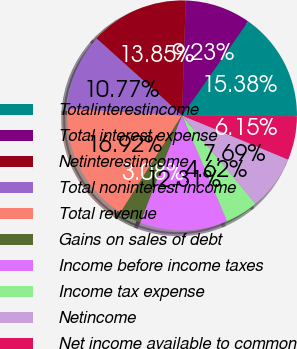<chart> <loc_0><loc_0><loc_500><loc_500><pie_chart><fcel>Totalinterestincome<fcel>Total interest expense<fcel>Netinterestincome<fcel>Total noninterest income<fcel>Total revenue<fcel>Gains on sales of debt<fcel>Income before income taxes<fcel>Income tax expense<fcel>Netincome<fcel>Net income available to common<nl><fcel>15.38%<fcel>9.23%<fcel>13.85%<fcel>10.77%<fcel>16.92%<fcel>3.08%<fcel>12.31%<fcel>4.62%<fcel>7.69%<fcel>6.15%<nl></chart> 